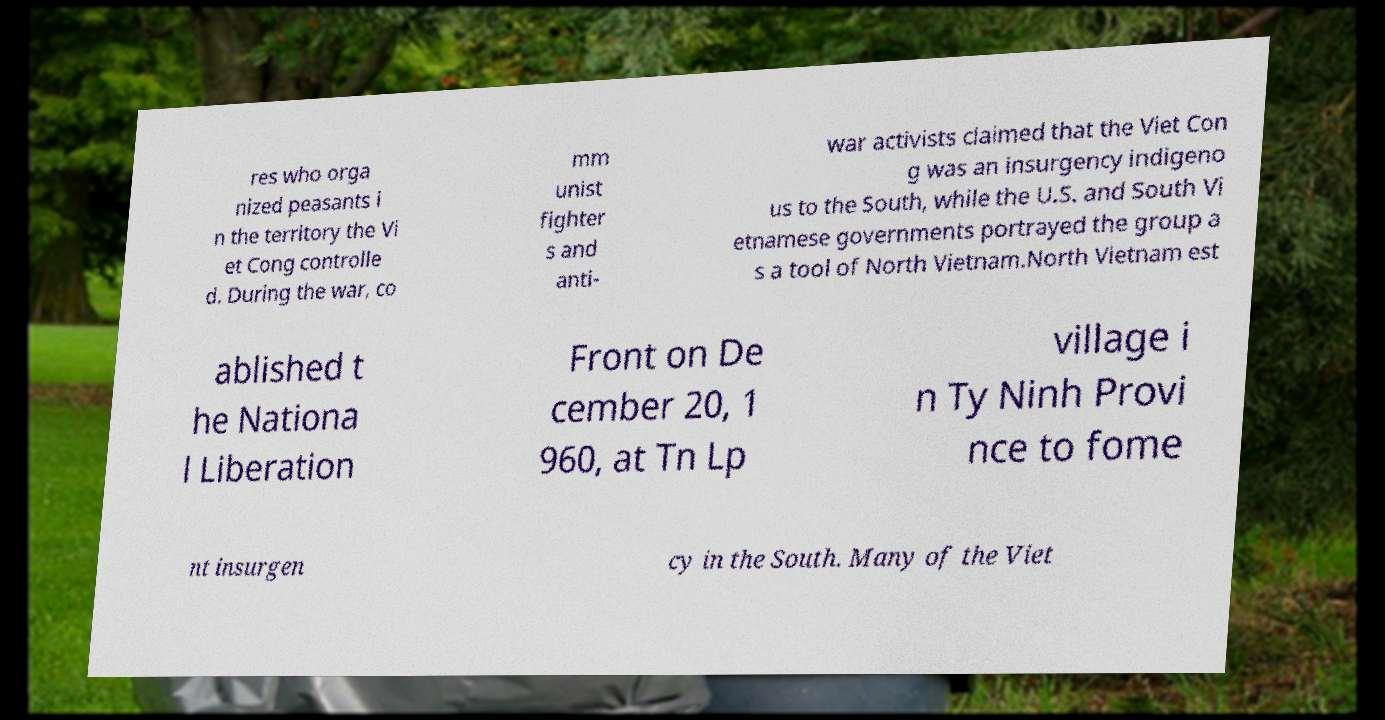I need the written content from this picture converted into text. Can you do that? res who orga nized peasants i n the territory the Vi et Cong controlle d. During the war, co mm unist fighter s and anti- war activists claimed that the Viet Con g was an insurgency indigeno us to the South, while the U.S. and South Vi etnamese governments portrayed the group a s a tool of North Vietnam.North Vietnam est ablished t he Nationa l Liberation Front on De cember 20, 1 960, at Tn Lp village i n Ty Ninh Provi nce to fome nt insurgen cy in the South. Many of the Viet 